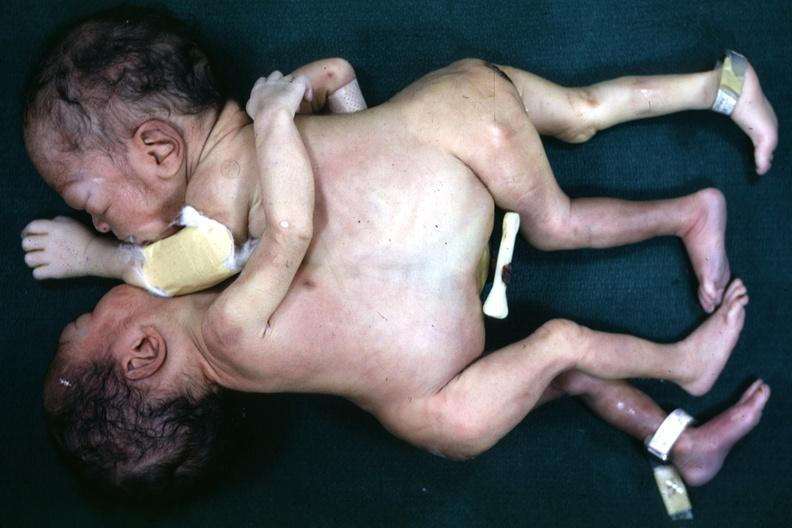what is present?
Answer the question using a single word or phrase. Siamese twins 